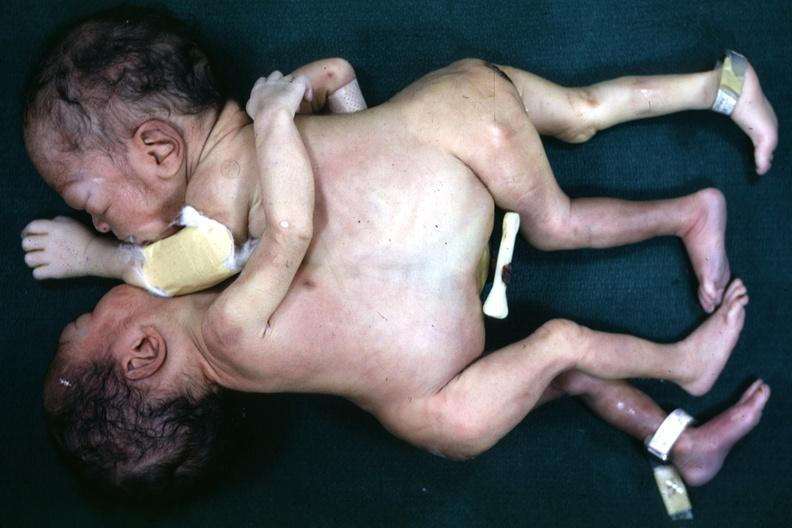what is present?
Answer the question using a single word or phrase. Siamese twins 